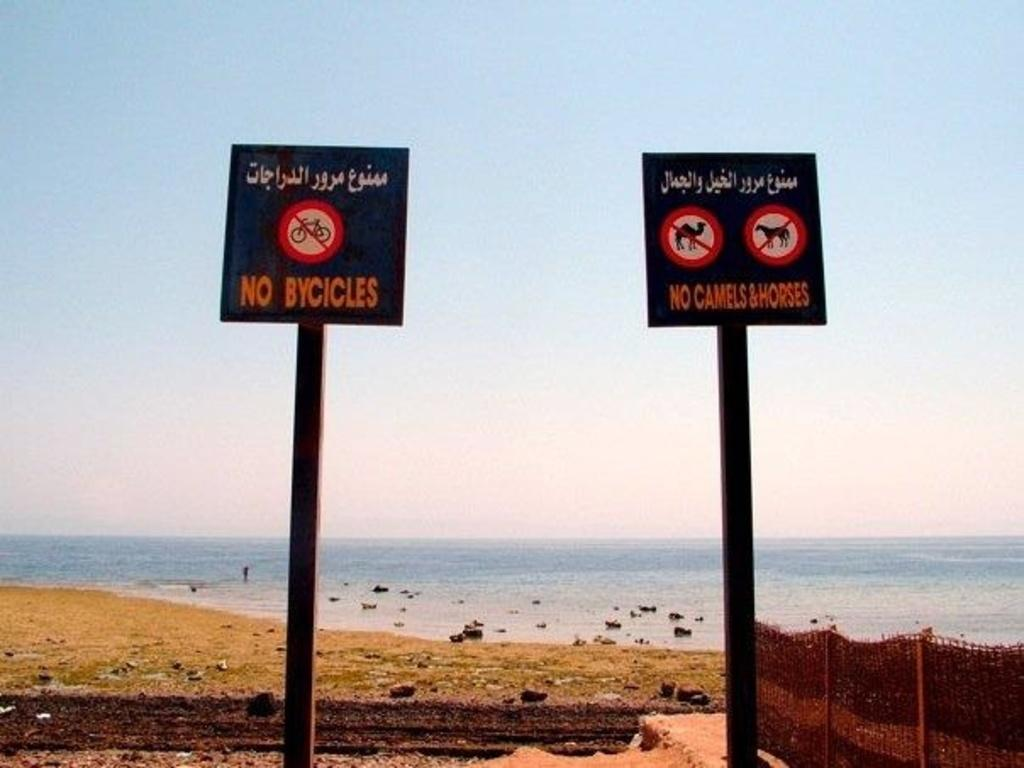<image>
Describe the image concisely. In front of a large body of water there are two signs, side by side, that say no bicycles, horses, or camels. 